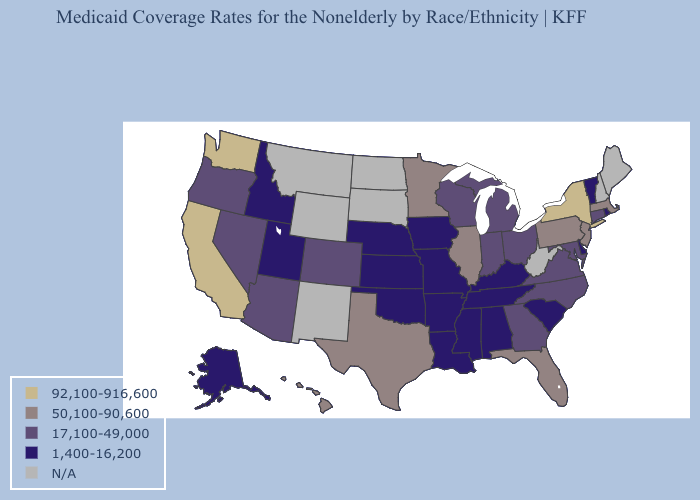Name the states that have a value in the range N/A?
Keep it brief. Maine, Montana, New Hampshire, New Mexico, North Dakota, South Dakota, West Virginia, Wyoming. What is the highest value in states that border Michigan?
Short answer required. 17,100-49,000. Name the states that have a value in the range 1,400-16,200?
Write a very short answer. Alabama, Alaska, Arkansas, Delaware, Idaho, Iowa, Kansas, Kentucky, Louisiana, Mississippi, Missouri, Nebraska, Oklahoma, Rhode Island, South Carolina, Tennessee, Utah, Vermont. Which states hav the highest value in the Northeast?
Write a very short answer. New York. What is the value of Virginia?
Concise answer only. 17,100-49,000. What is the value of Delaware?
Short answer required. 1,400-16,200. Among the states that border Minnesota , does Wisconsin have the lowest value?
Answer briefly. No. Does Connecticut have the highest value in the Northeast?
Short answer required. No. What is the highest value in the USA?
Quick response, please. 92,100-916,600. Name the states that have a value in the range 17,100-49,000?
Concise answer only. Arizona, Colorado, Connecticut, Georgia, Indiana, Maryland, Michigan, Nevada, North Carolina, Ohio, Oregon, Virginia, Wisconsin. Name the states that have a value in the range 50,100-90,600?
Keep it brief. Florida, Hawaii, Illinois, Massachusetts, Minnesota, New Jersey, Pennsylvania, Texas. What is the value of North Carolina?
Keep it brief. 17,100-49,000. 